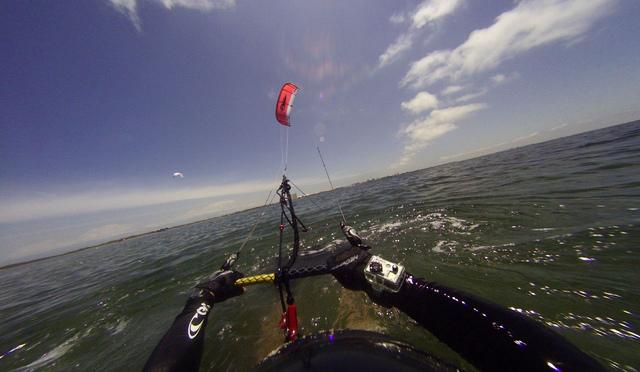Is this a surfer?
Give a very brief answer. No. What sport is this?
Give a very brief answer. Parasailing. Is this person wet?
Concise answer only. Yes. 